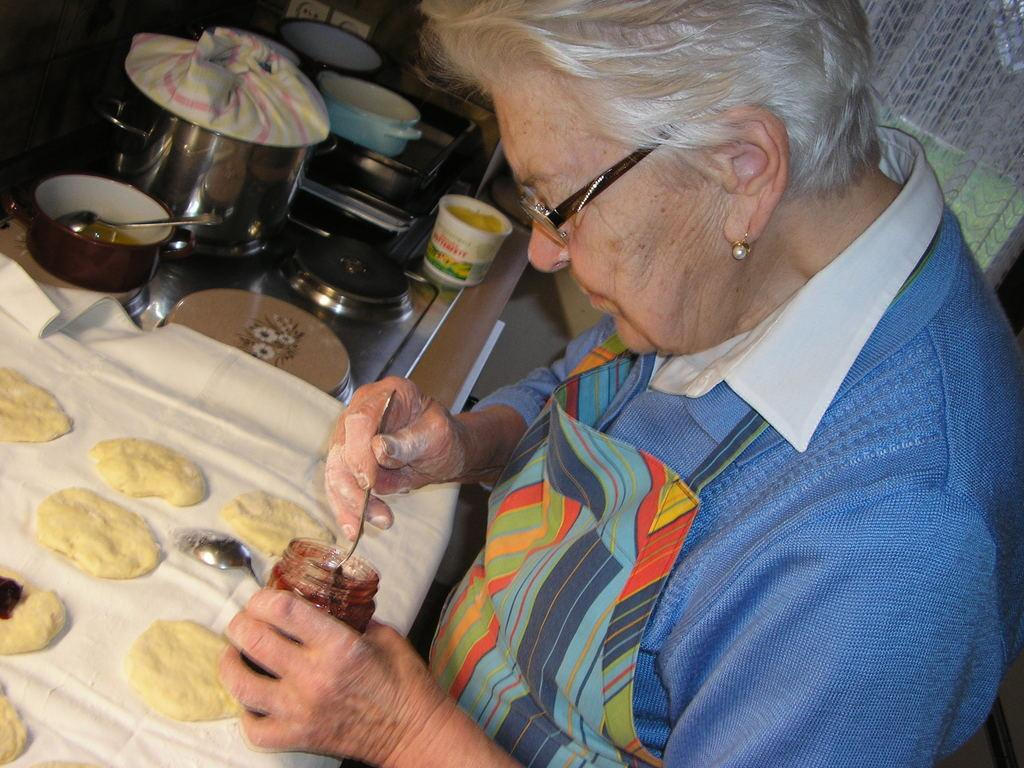Who is present in the image? There is a woman in the image. What is the woman doing in the image? The woman is standing in the image. What objects is the woman holding? The woman is holding a bottle and a spoon in the image. What is in front of the woman? There is a cloth in front of the woman. What other items can be seen in the image? There are bowls, a cup, and two spoons in the image. What type of mitten is the woman wearing in the image? There is no mitten present in the image; the woman is not wearing any gloves or mittens. What is the woman using the celery for in the image? There is no celery present in the image, so it cannot be used for any purpose. 